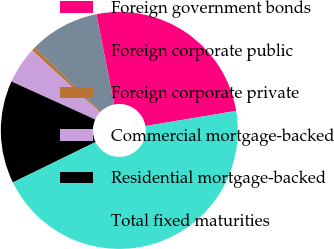Convert chart. <chart><loc_0><loc_0><loc_500><loc_500><pie_chart><fcel>Foreign government bonds<fcel>Foreign corporate public<fcel>Foreign corporate private<fcel>Commercial mortgage-backed<fcel>Residential mortgage-backed<fcel>Total fixed maturities<nl><fcel>25.47%<fcel>9.52%<fcel>0.55%<fcel>5.04%<fcel>14.01%<fcel>45.4%<nl></chart> 